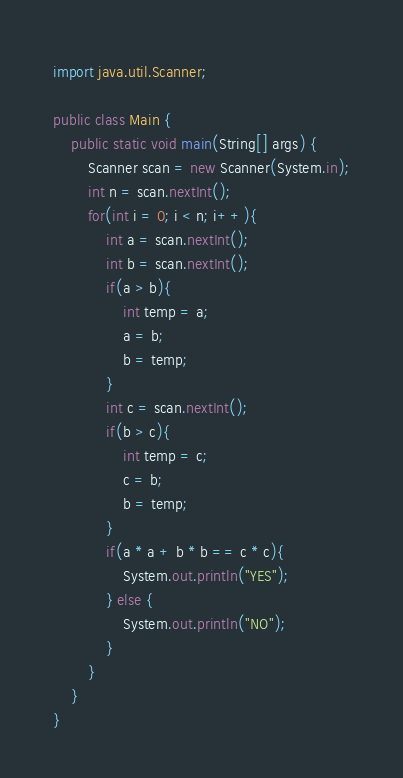Convert code to text. <code><loc_0><loc_0><loc_500><loc_500><_Java_>import java.util.Scanner;

public class Main {
    public static void main(String[] args) {
        Scanner scan = new Scanner(System.in);
        int n = scan.nextInt();
        for(int i = 0; i < n; i++){
            int a = scan.nextInt();
            int b = scan.nextInt();
            if(a > b){
                int temp = a;
                a = b;
                b = temp;
            }
            int c = scan.nextInt();
            if(b > c){
                int temp = c;
                c = b;
                b = temp;
            }
            if(a * a + b * b == c * c){
                System.out.println("YES");
            } else {
                System.out.println("NO");
            }
        }
    }
}

</code> 